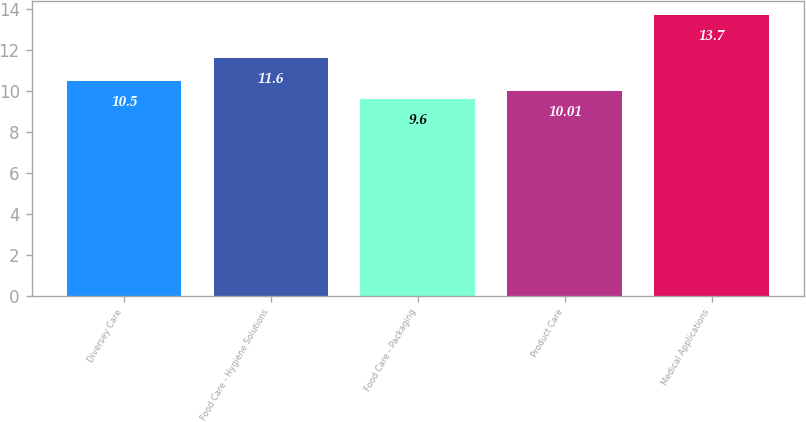Convert chart to OTSL. <chart><loc_0><loc_0><loc_500><loc_500><bar_chart><fcel>Diversey Care<fcel>Food Care - Hygiene Solutions<fcel>Food Care - Packaging<fcel>Product Care<fcel>Medical Applications<nl><fcel>10.5<fcel>11.6<fcel>9.6<fcel>10.01<fcel>13.7<nl></chart> 